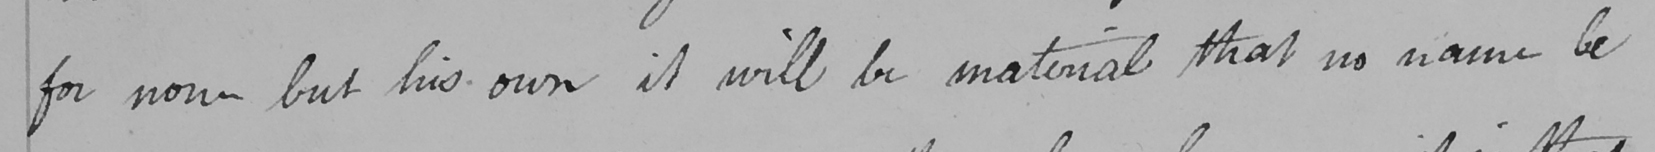Can you tell me what this handwritten text says? for none but his own it will be material that no name be 